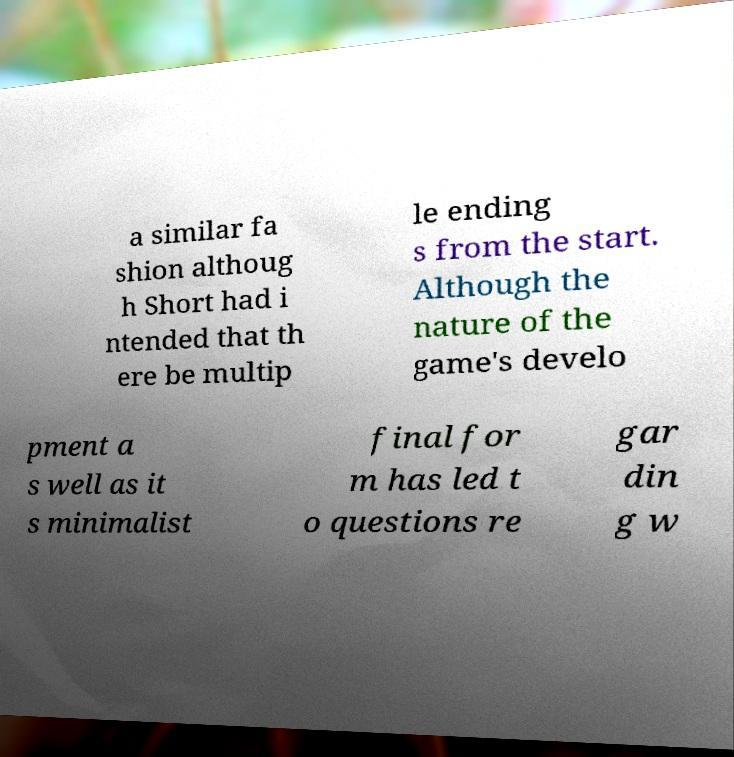Could you extract and type out the text from this image? a similar fa shion althoug h Short had i ntended that th ere be multip le ending s from the start. Although the nature of the game's develo pment a s well as it s minimalist final for m has led t o questions re gar din g w 